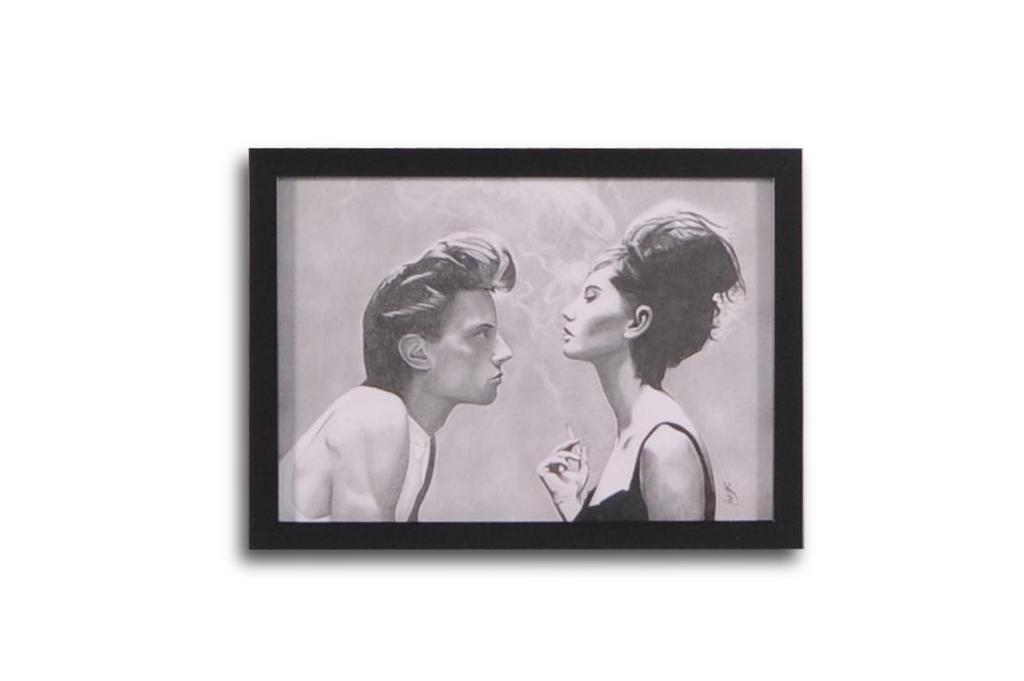What object is present in the image that typically holds a photograph? There is a photo frame in the image. What can be seen inside the photo frame? The photo frame contains a picture of a man and a woman. What is the woman in the photo doing? The woman in the photo is holding a cigarette. What color is the background of the image? The background of the image is white. How does the sand in the image contribute to the purpose of the photo frame? There is no sand present in the image, so it cannot contribute to the purpose of the photo frame. 